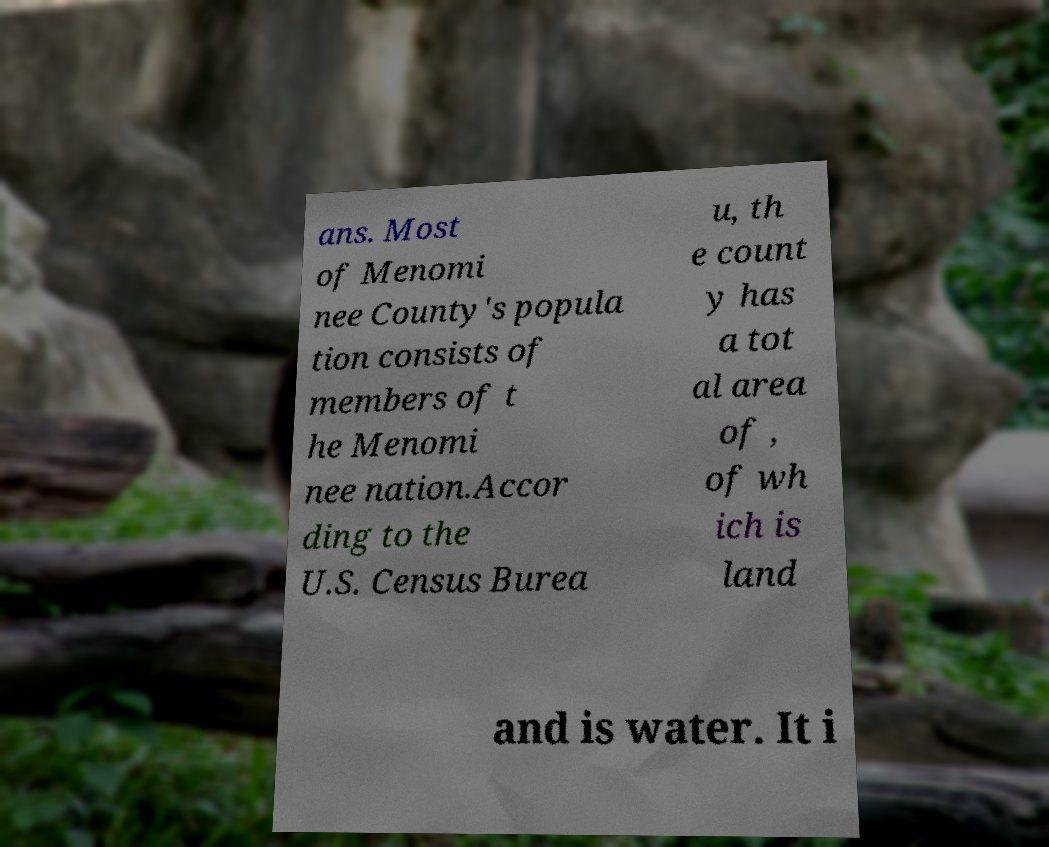I need the written content from this picture converted into text. Can you do that? ans. Most of Menomi nee County's popula tion consists of members of t he Menomi nee nation.Accor ding to the U.S. Census Burea u, th e count y has a tot al area of , of wh ich is land and is water. It i 